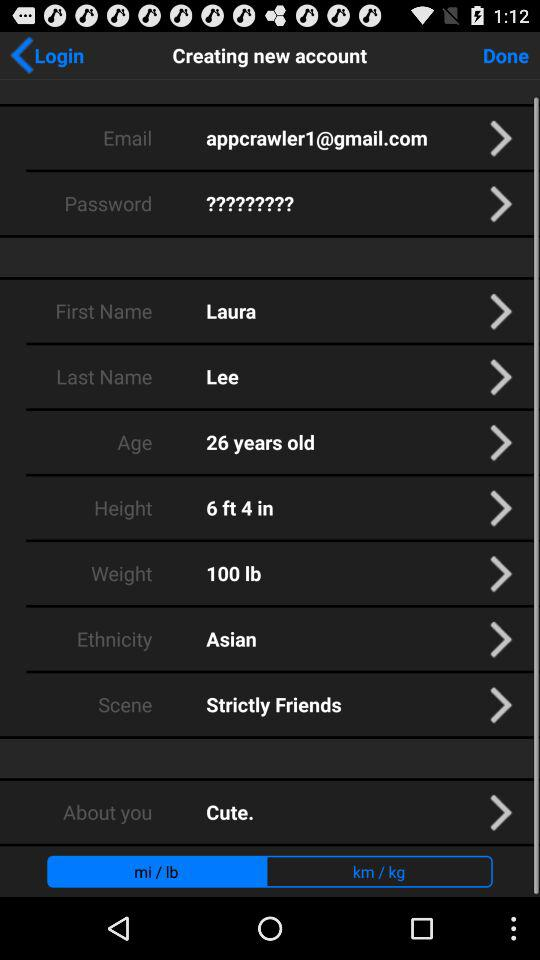What is the given weight? The weight is 100 lbs. 